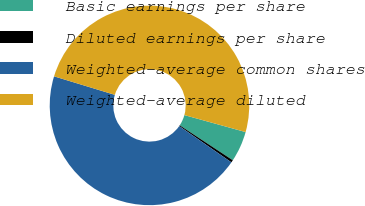Convert chart to OTSL. <chart><loc_0><loc_0><loc_500><loc_500><pie_chart><fcel>Basic earnings per share<fcel>Diluted earnings per share<fcel>Weighted-average common shares<fcel>Weighted-average diluted<nl><fcel>4.96%<fcel>0.4%<fcel>45.04%<fcel>49.6%<nl></chart> 